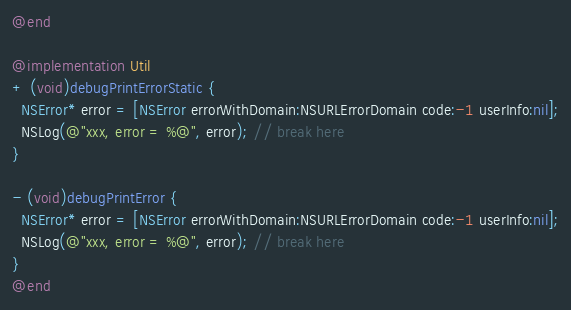Convert code to text. <code><loc_0><loc_0><loc_500><loc_500><_ObjectiveC_>@end

@implementation Util
+ (void)debugPrintErrorStatic {
  NSError* error = [NSError errorWithDomain:NSURLErrorDomain code:-1 userInfo:nil];
  NSLog(@"xxx, error = %@", error); // break here
}

- (void)debugPrintError {
  NSError* error = [NSError errorWithDomain:NSURLErrorDomain code:-1 userInfo:nil];
  NSLog(@"xxx, error = %@", error); // break here
}
@end
</code> 